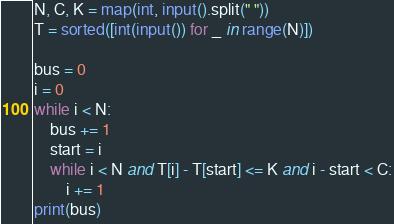<code> <loc_0><loc_0><loc_500><loc_500><_Python_>N, C, K = map(int, input().split(" "))
T = sorted([int(input()) for _ in range(N)])

bus = 0
i = 0
while i < N:
    bus += 1
    start = i
    while i < N and T[i] - T[start] <= K and i - start < C:
        i += 1
print(bus)</code> 